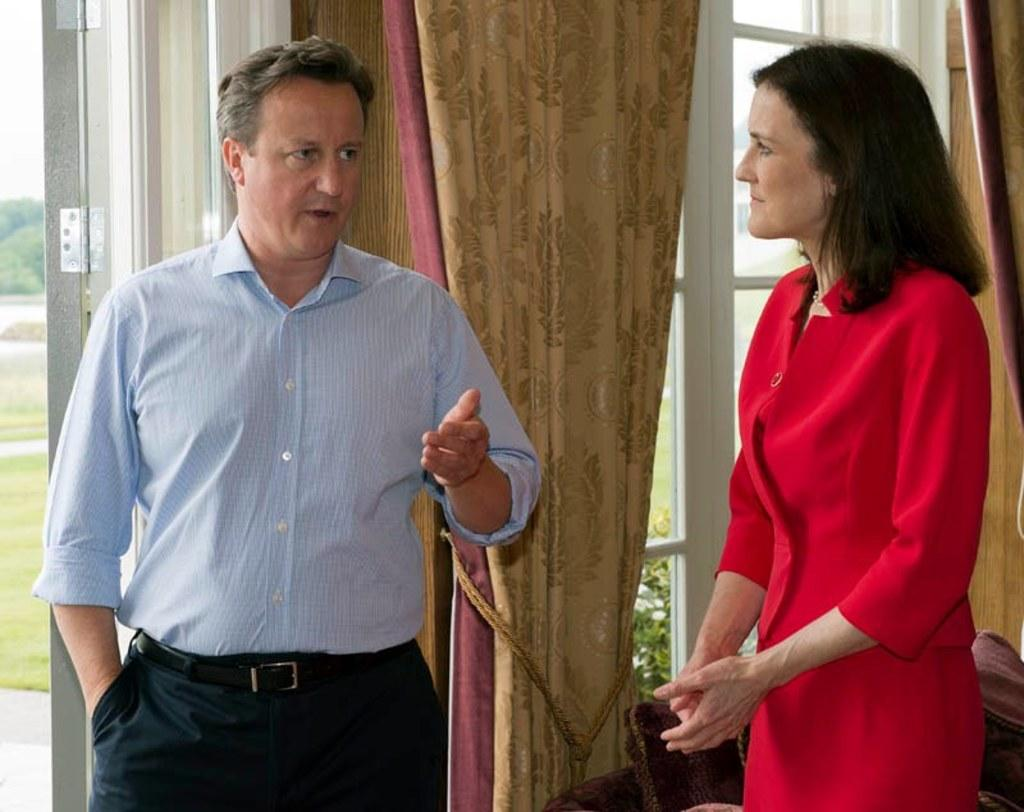How many people are present in the image? There are two people, a man and a woman, present in the image. What can be seen in the background of the image? There are windows, a curtain, and a door in the background of the image. What is visible outside the window? There is greenery visible outside the window. What shape is the ladybug in the image? There is no ladybug present in the image. 